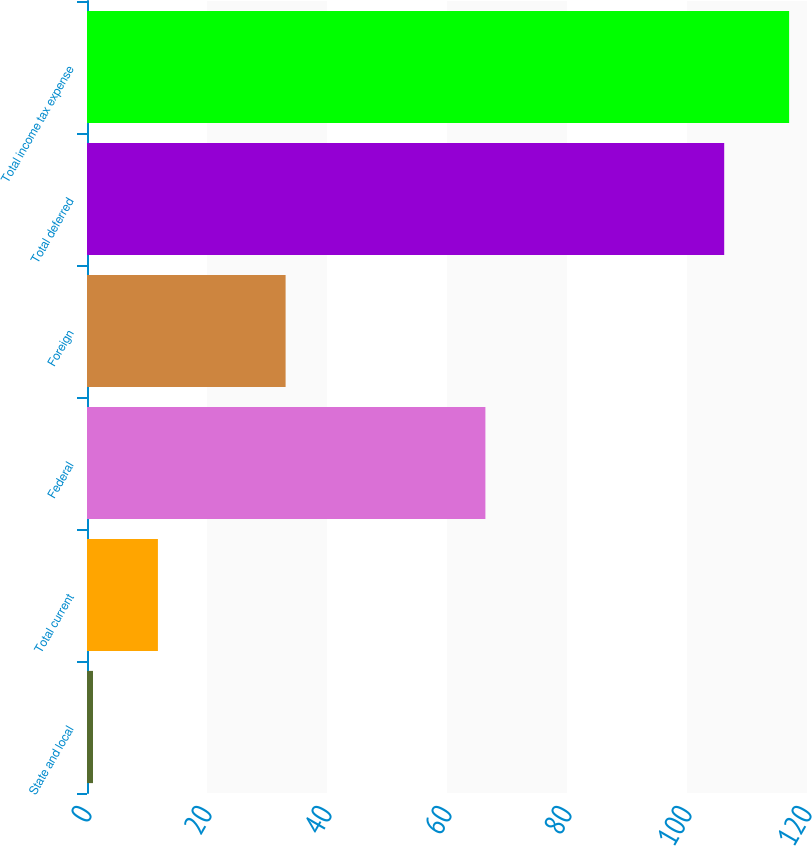Convert chart to OTSL. <chart><loc_0><loc_0><loc_500><loc_500><bar_chart><fcel>State and local<fcel>Total current<fcel>Federal<fcel>Foreign<fcel>Total deferred<fcel>Total income tax expense<nl><fcel>1<fcel>11.82<fcel>66.4<fcel>33.1<fcel>106.2<fcel>117.02<nl></chart> 